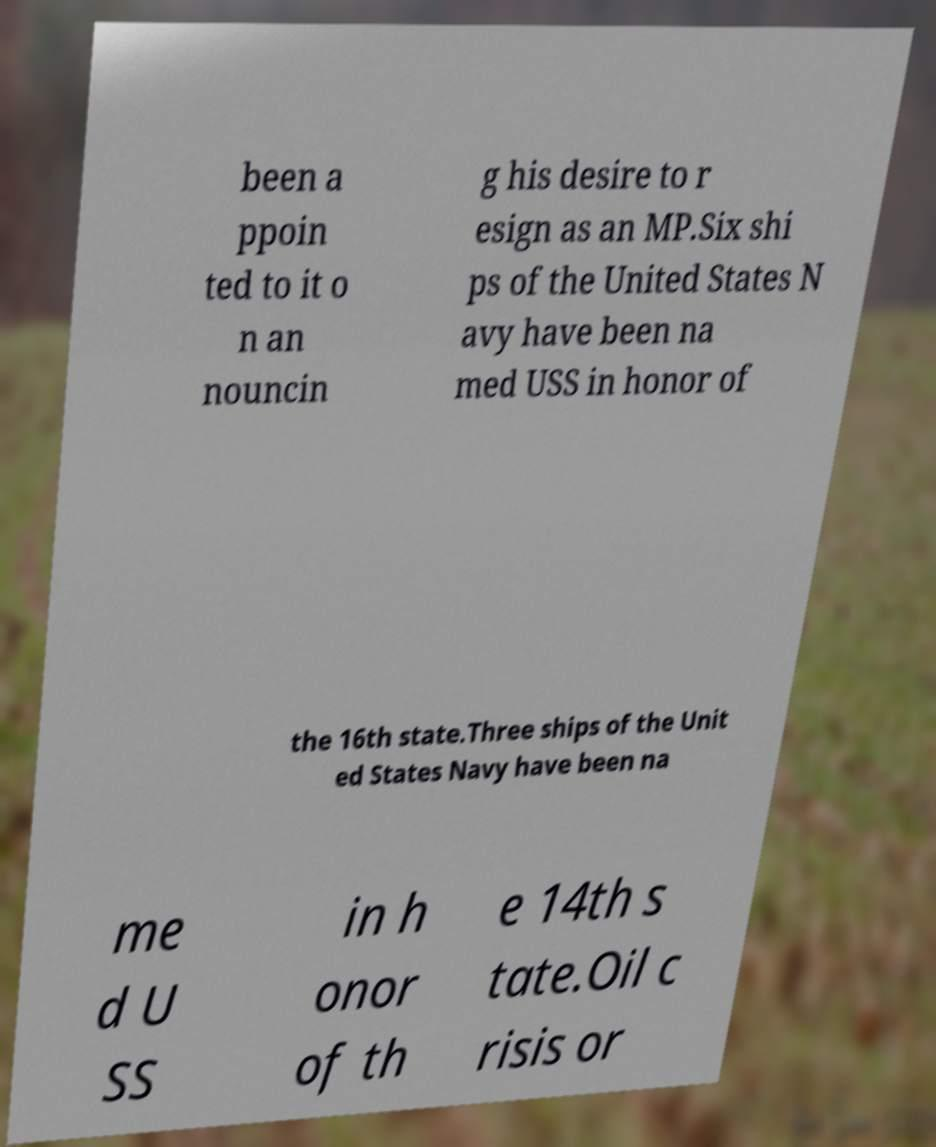What messages or text are displayed in this image? I need them in a readable, typed format. been a ppoin ted to it o n an nouncin g his desire to r esign as an MP.Six shi ps of the United States N avy have been na med USS in honor of the 16th state.Three ships of the Unit ed States Navy have been na me d U SS in h onor of th e 14th s tate.Oil c risis or 